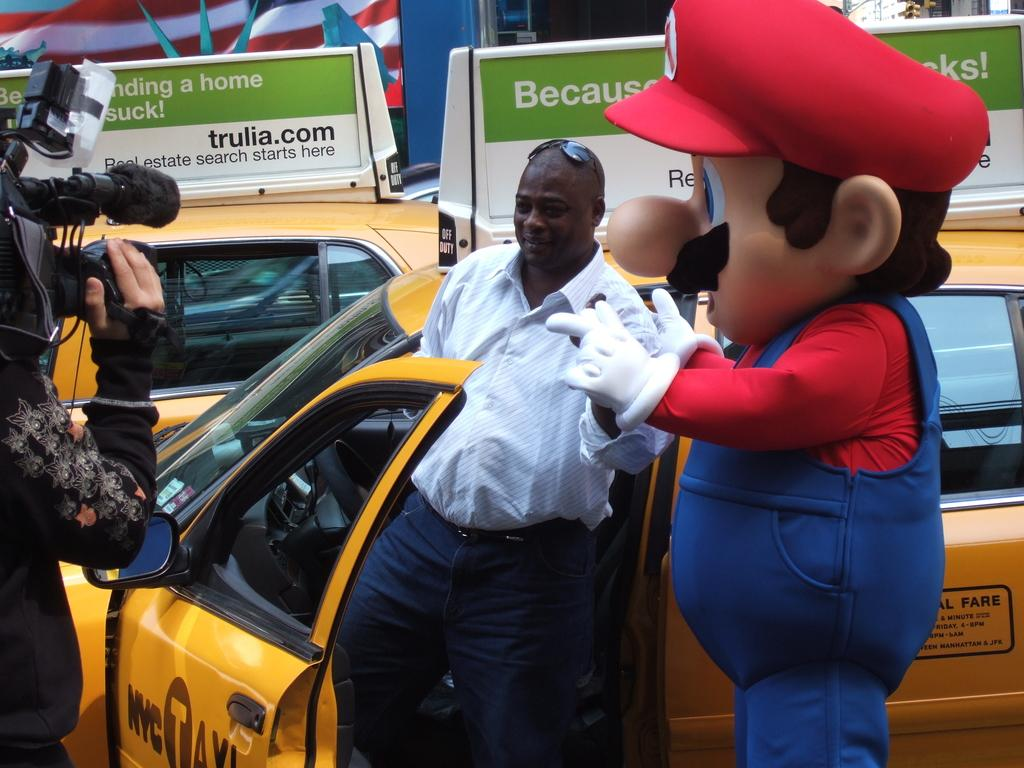<image>
Offer a succinct explanation of the picture presented. A man getting out of an NYC taxi with Mario with trulia.com advertising on top of the car. 